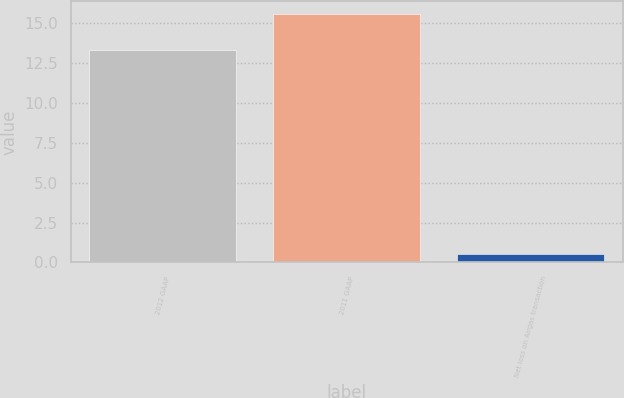Convert chart to OTSL. <chart><loc_0><loc_0><loc_500><loc_500><bar_chart><fcel>2012 GAAP<fcel>2011 GAAP<fcel>Net loss on Airgas transaction<nl><fcel>13.3<fcel>15.6<fcel>0.5<nl></chart> 